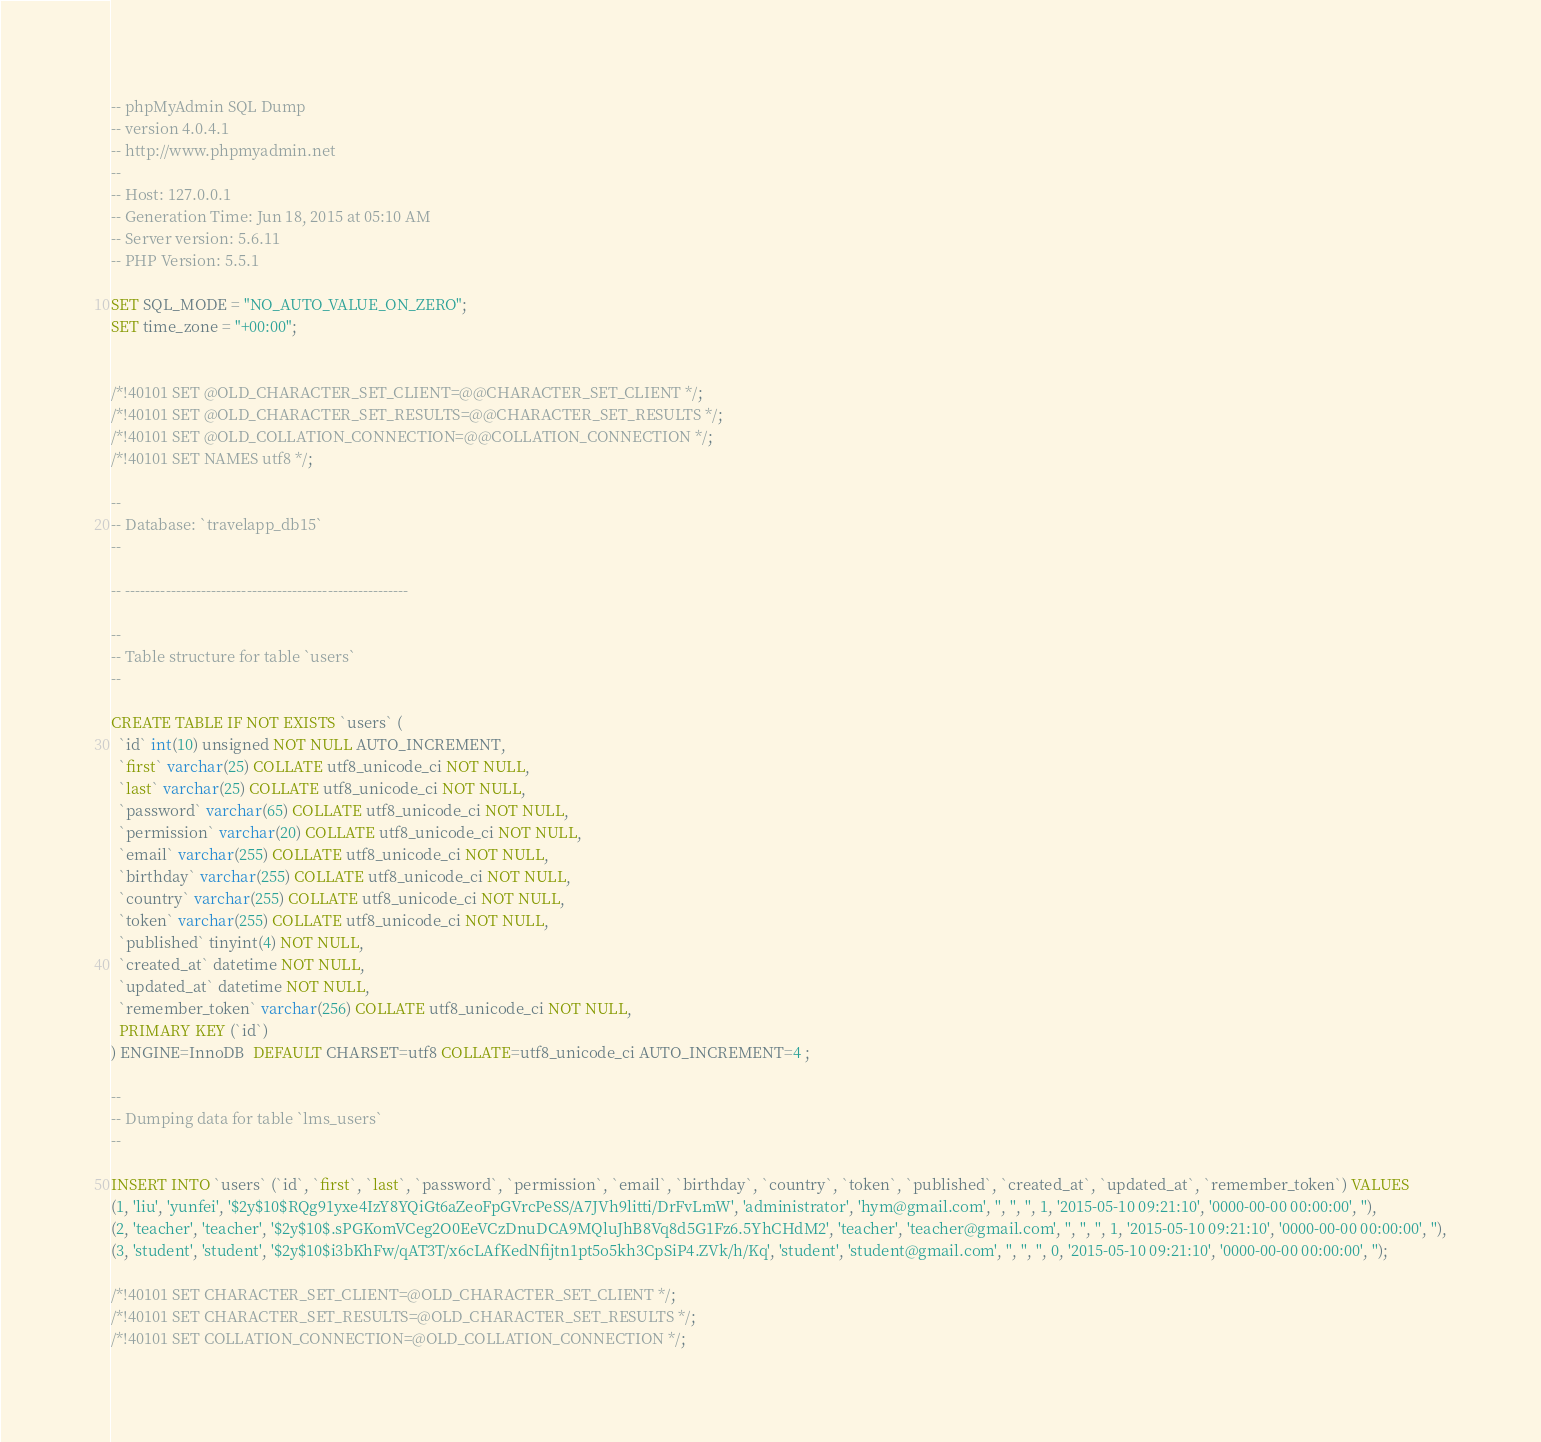<code> <loc_0><loc_0><loc_500><loc_500><_SQL_>-- phpMyAdmin SQL Dump
-- version 4.0.4.1
-- http://www.phpmyadmin.net
--
-- Host: 127.0.0.1
-- Generation Time: Jun 18, 2015 at 05:10 AM
-- Server version: 5.6.11
-- PHP Version: 5.5.1

SET SQL_MODE = "NO_AUTO_VALUE_ON_ZERO";
SET time_zone = "+00:00";


/*!40101 SET @OLD_CHARACTER_SET_CLIENT=@@CHARACTER_SET_CLIENT */;
/*!40101 SET @OLD_CHARACTER_SET_RESULTS=@@CHARACTER_SET_RESULTS */;
/*!40101 SET @OLD_COLLATION_CONNECTION=@@COLLATION_CONNECTION */;
/*!40101 SET NAMES utf8 */;

--
-- Database: `travelapp_db15`
--

-- --------------------------------------------------------

--
-- Table structure for table `users`
--

CREATE TABLE IF NOT EXISTS `users` (
  `id` int(10) unsigned NOT NULL AUTO_INCREMENT,
  `first` varchar(25) COLLATE utf8_unicode_ci NOT NULL,
  `last` varchar(25) COLLATE utf8_unicode_ci NOT NULL,
  `password` varchar(65) COLLATE utf8_unicode_ci NOT NULL,
  `permission` varchar(20) COLLATE utf8_unicode_ci NOT NULL,
  `email` varchar(255) COLLATE utf8_unicode_ci NOT NULL,
  `birthday` varchar(255) COLLATE utf8_unicode_ci NOT NULL,
  `country` varchar(255) COLLATE utf8_unicode_ci NOT NULL,
  `token` varchar(255) COLLATE utf8_unicode_ci NOT NULL,
  `published` tinyint(4) NOT NULL,
  `created_at` datetime NOT NULL,
  `updated_at` datetime NOT NULL,
  `remember_token` varchar(256) COLLATE utf8_unicode_ci NOT NULL,
  PRIMARY KEY (`id`)
) ENGINE=InnoDB  DEFAULT CHARSET=utf8 COLLATE=utf8_unicode_ci AUTO_INCREMENT=4 ;

--
-- Dumping data for table `lms_users`
--

INSERT INTO `users` (`id`, `first`, `last`, `password`, `permission`, `email`, `birthday`, `country`, `token`, `published`, `created_at`, `updated_at`, `remember_token`) VALUES
(1, 'liu', 'yunfei', '$2y$10$RQg91yxe4IzY8YQiGt6aZeoFpGVrcPeSS/A7JVh9litti/DrFvLmW', 'administrator', 'hym@gmail.com', '', '', '', 1, '2015-05-10 09:21:10', '0000-00-00 00:00:00', ''),
(2, 'teacher', 'teacher', '$2y$10$.sPGKomVCeg2O0EeVCzDnuDCA9MQluJhB8Vq8d5G1Fz6.5YhCHdM2', 'teacher', 'teacher@gmail.com', '', '', '', 1, '2015-05-10 09:21:10', '0000-00-00 00:00:00', ''),
(3, 'student', 'student', '$2y$10$i3bKhFw/qAT3T/x6cLAfKedNfijtn1pt5o5kh3CpSiP4.ZVk/h/Kq', 'student', 'student@gmail.com', '', '', '', 0, '2015-05-10 09:21:10', '0000-00-00 00:00:00', '');

/*!40101 SET CHARACTER_SET_CLIENT=@OLD_CHARACTER_SET_CLIENT */;
/*!40101 SET CHARACTER_SET_RESULTS=@OLD_CHARACTER_SET_RESULTS */;
/*!40101 SET COLLATION_CONNECTION=@OLD_COLLATION_CONNECTION */;
</code> 